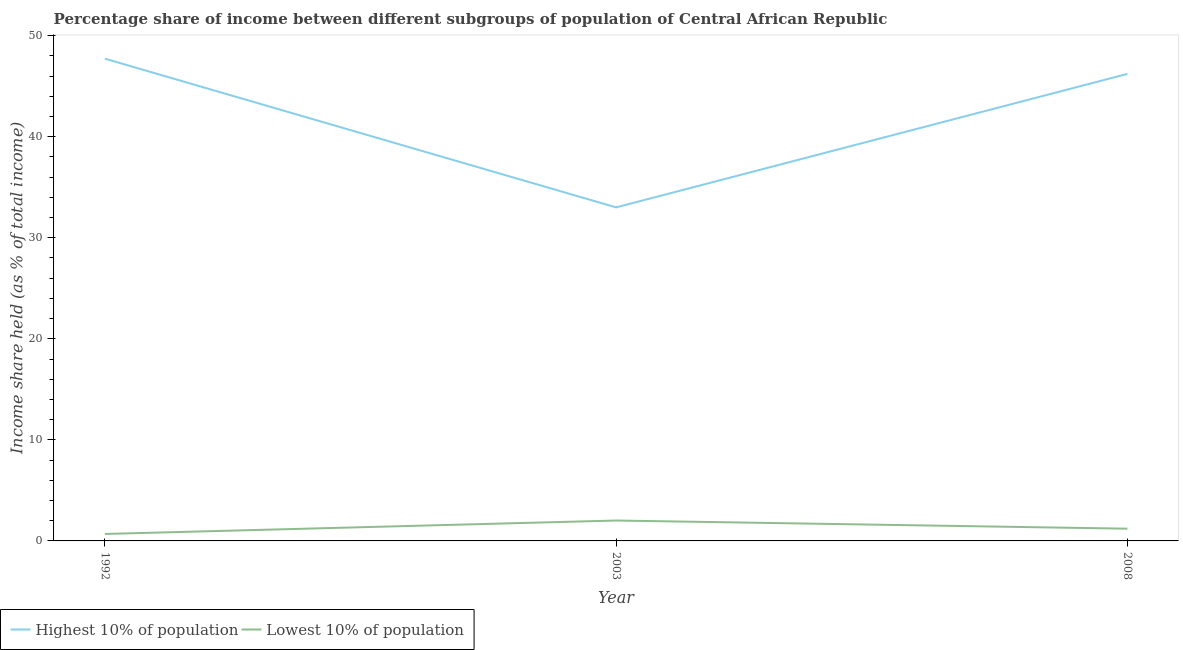How many different coloured lines are there?
Offer a very short reply. 2. What is the income share held by highest 10% of the population in 1992?
Keep it short and to the point. 47.73. Across all years, what is the maximum income share held by lowest 10% of the population?
Your answer should be very brief. 2.02. Across all years, what is the minimum income share held by highest 10% of the population?
Provide a succinct answer. 33.01. In which year was the income share held by highest 10% of the population minimum?
Provide a succinct answer. 2003. What is the total income share held by highest 10% of the population in the graph?
Make the answer very short. 126.96. What is the difference between the income share held by lowest 10% of the population in 1992 and that in 2008?
Your answer should be compact. -0.52. What is the difference between the income share held by lowest 10% of the population in 2003 and the income share held by highest 10% of the population in 1992?
Ensure brevity in your answer.  -45.71. What is the average income share held by highest 10% of the population per year?
Ensure brevity in your answer.  42.32. In the year 2008, what is the difference between the income share held by highest 10% of the population and income share held by lowest 10% of the population?
Ensure brevity in your answer.  45.01. What is the ratio of the income share held by highest 10% of the population in 2003 to that in 2008?
Your answer should be compact. 0.71. Is the income share held by highest 10% of the population in 2003 less than that in 2008?
Offer a very short reply. Yes. Is the difference between the income share held by highest 10% of the population in 1992 and 2008 greater than the difference between the income share held by lowest 10% of the population in 1992 and 2008?
Make the answer very short. Yes. What is the difference between the highest and the second highest income share held by highest 10% of the population?
Your answer should be compact. 1.51. What is the difference between the highest and the lowest income share held by lowest 10% of the population?
Offer a terse response. 1.33. Is the sum of the income share held by lowest 10% of the population in 1992 and 2008 greater than the maximum income share held by highest 10% of the population across all years?
Provide a succinct answer. No. Is the income share held by highest 10% of the population strictly greater than the income share held by lowest 10% of the population over the years?
Ensure brevity in your answer.  Yes. How many lines are there?
Provide a succinct answer. 2. What is the difference between two consecutive major ticks on the Y-axis?
Your answer should be very brief. 10. Are the values on the major ticks of Y-axis written in scientific E-notation?
Offer a very short reply. No. Does the graph contain any zero values?
Offer a very short reply. No. How many legend labels are there?
Keep it short and to the point. 2. How are the legend labels stacked?
Provide a succinct answer. Horizontal. What is the title of the graph?
Give a very brief answer. Percentage share of income between different subgroups of population of Central African Republic. What is the label or title of the Y-axis?
Provide a short and direct response. Income share held (as % of total income). What is the Income share held (as % of total income) in Highest 10% of population in 1992?
Make the answer very short. 47.73. What is the Income share held (as % of total income) in Lowest 10% of population in 1992?
Ensure brevity in your answer.  0.69. What is the Income share held (as % of total income) in Highest 10% of population in 2003?
Provide a succinct answer. 33.01. What is the Income share held (as % of total income) in Lowest 10% of population in 2003?
Keep it short and to the point. 2.02. What is the Income share held (as % of total income) of Highest 10% of population in 2008?
Your answer should be compact. 46.22. What is the Income share held (as % of total income) of Lowest 10% of population in 2008?
Give a very brief answer. 1.21. Across all years, what is the maximum Income share held (as % of total income) in Highest 10% of population?
Make the answer very short. 47.73. Across all years, what is the maximum Income share held (as % of total income) of Lowest 10% of population?
Provide a succinct answer. 2.02. Across all years, what is the minimum Income share held (as % of total income) of Highest 10% of population?
Provide a succinct answer. 33.01. Across all years, what is the minimum Income share held (as % of total income) of Lowest 10% of population?
Your answer should be compact. 0.69. What is the total Income share held (as % of total income) of Highest 10% of population in the graph?
Offer a very short reply. 126.96. What is the total Income share held (as % of total income) of Lowest 10% of population in the graph?
Your answer should be compact. 3.92. What is the difference between the Income share held (as % of total income) in Highest 10% of population in 1992 and that in 2003?
Make the answer very short. 14.72. What is the difference between the Income share held (as % of total income) in Lowest 10% of population in 1992 and that in 2003?
Make the answer very short. -1.33. What is the difference between the Income share held (as % of total income) of Highest 10% of population in 1992 and that in 2008?
Provide a short and direct response. 1.51. What is the difference between the Income share held (as % of total income) of Lowest 10% of population in 1992 and that in 2008?
Provide a short and direct response. -0.52. What is the difference between the Income share held (as % of total income) of Highest 10% of population in 2003 and that in 2008?
Provide a succinct answer. -13.21. What is the difference between the Income share held (as % of total income) of Lowest 10% of population in 2003 and that in 2008?
Ensure brevity in your answer.  0.81. What is the difference between the Income share held (as % of total income) in Highest 10% of population in 1992 and the Income share held (as % of total income) in Lowest 10% of population in 2003?
Keep it short and to the point. 45.71. What is the difference between the Income share held (as % of total income) of Highest 10% of population in 1992 and the Income share held (as % of total income) of Lowest 10% of population in 2008?
Give a very brief answer. 46.52. What is the difference between the Income share held (as % of total income) in Highest 10% of population in 2003 and the Income share held (as % of total income) in Lowest 10% of population in 2008?
Give a very brief answer. 31.8. What is the average Income share held (as % of total income) in Highest 10% of population per year?
Keep it short and to the point. 42.32. What is the average Income share held (as % of total income) in Lowest 10% of population per year?
Provide a short and direct response. 1.31. In the year 1992, what is the difference between the Income share held (as % of total income) in Highest 10% of population and Income share held (as % of total income) in Lowest 10% of population?
Keep it short and to the point. 47.04. In the year 2003, what is the difference between the Income share held (as % of total income) in Highest 10% of population and Income share held (as % of total income) in Lowest 10% of population?
Ensure brevity in your answer.  30.99. In the year 2008, what is the difference between the Income share held (as % of total income) of Highest 10% of population and Income share held (as % of total income) of Lowest 10% of population?
Your answer should be very brief. 45.01. What is the ratio of the Income share held (as % of total income) in Highest 10% of population in 1992 to that in 2003?
Offer a terse response. 1.45. What is the ratio of the Income share held (as % of total income) in Lowest 10% of population in 1992 to that in 2003?
Your answer should be very brief. 0.34. What is the ratio of the Income share held (as % of total income) of Highest 10% of population in 1992 to that in 2008?
Ensure brevity in your answer.  1.03. What is the ratio of the Income share held (as % of total income) in Lowest 10% of population in 1992 to that in 2008?
Your answer should be very brief. 0.57. What is the ratio of the Income share held (as % of total income) of Highest 10% of population in 2003 to that in 2008?
Your answer should be very brief. 0.71. What is the ratio of the Income share held (as % of total income) in Lowest 10% of population in 2003 to that in 2008?
Your answer should be very brief. 1.67. What is the difference between the highest and the second highest Income share held (as % of total income) of Highest 10% of population?
Provide a short and direct response. 1.51. What is the difference between the highest and the second highest Income share held (as % of total income) of Lowest 10% of population?
Your answer should be compact. 0.81. What is the difference between the highest and the lowest Income share held (as % of total income) of Highest 10% of population?
Provide a short and direct response. 14.72. What is the difference between the highest and the lowest Income share held (as % of total income) of Lowest 10% of population?
Offer a terse response. 1.33. 